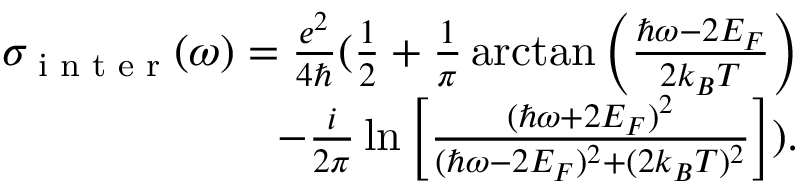Convert formula to latex. <formula><loc_0><loc_0><loc_500><loc_500>\begin{array} { r } { \sigma _ { i n t e r } ( \omega ) = \frac { e ^ { 2 } } { 4 } ( \frac { 1 } { 2 } + \frac { 1 } { \pi } \arctan \left ( \frac { \hbar { \omega } - 2 E _ { F } } { 2 k _ { B } T } \right ) } \\ { - \frac { i } { 2 \pi } \ln \left [ \frac { ( \hbar { \omega } + 2 E _ { F } ) ^ { 2 } } { ( \hbar { \omega } - 2 E _ { F } ) ^ { 2 } + ( 2 k _ { B } T ) ^ { 2 } } \right ] ) . } \end{array}</formula> 